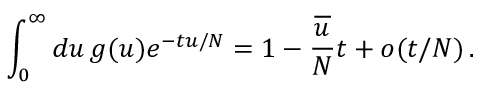<formula> <loc_0><loc_0><loc_500><loc_500>\int _ { 0 } ^ { \infty } d u \, g ( u ) e ^ { - t u / N } = 1 - \frac { \overline { u } } { N } t + o ( t / N ) \, .</formula> 